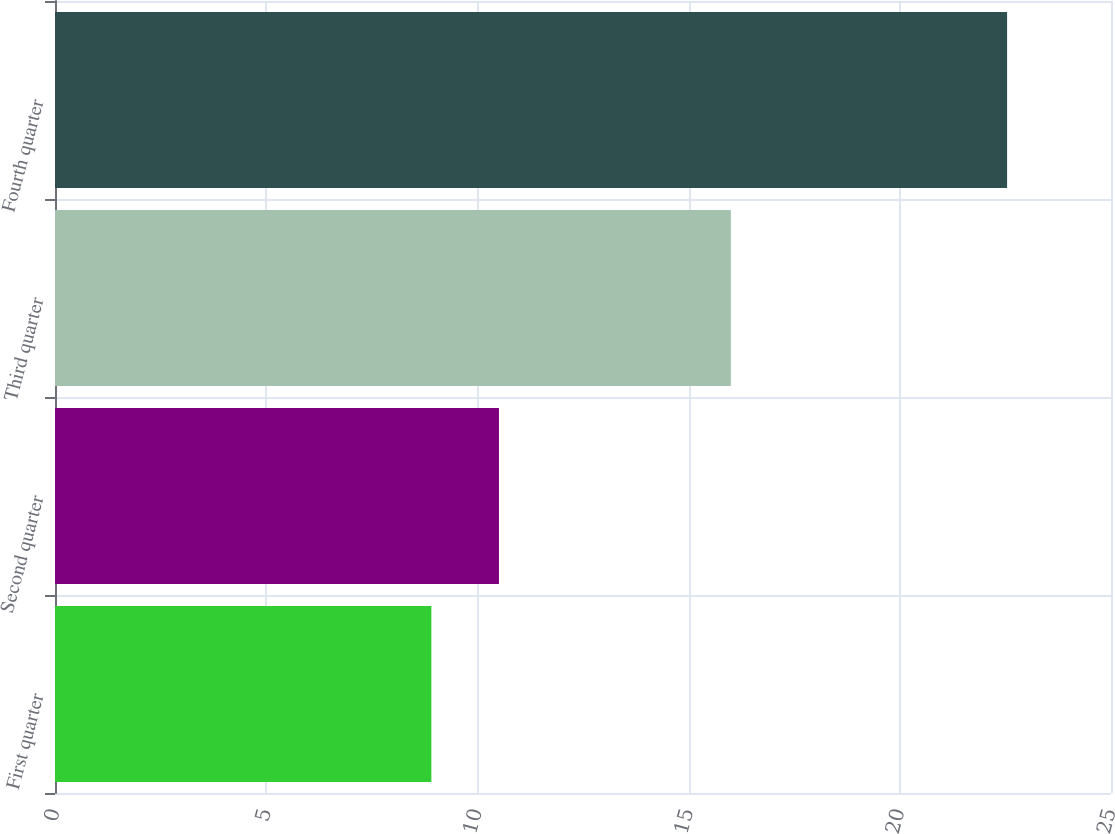Convert chart to OTSL. <chart><loc_0><loc_0><loc_500><loc_500><bar_chart><fcel>First quarter<fcel>Second quarter<fcel>Third quarter<fcel>Fourth quarter<nl><fcel>8.91<fcel>10.51<fcel>16<fcel>22.54<nl></chart> 